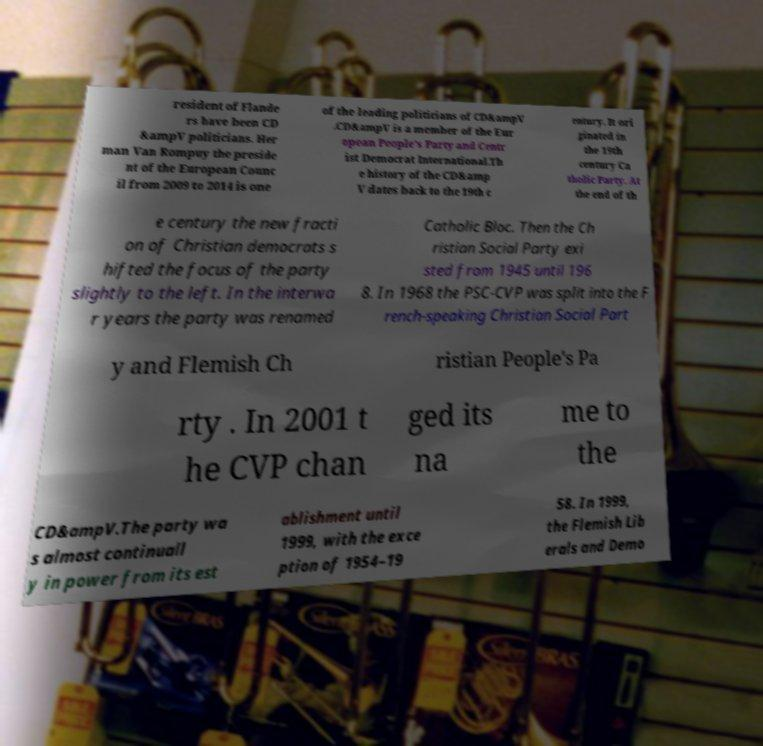What messages or text are displayed in this image? I need them in a readable, typed format. resident of Flande rs have been CD &ampV politicians. Her man Van Rompuy the preside nt of the European Counc il from 2009 to 2014 is one of the leading politicians of CD&ampV .CD&ampV is a member of the Eur opean People's Party and Centr ist Democrat International.Th e history of the CD&amp V dates back to the 19th c entury. It ori ginated in the 19th century Ca tholic Party. At the end of th e century the new fracti on of Christian democrats s hifted the focus of the party slightly to the left. In the interwa r years the party was renamed Catholic Bloc. Then the Ch ristian Social Party exi sted from 1945 until 196 8. In 1968 the PSC-CVP was split into the F rench-speaking Christian Social Part y and Flemish Ch ristian People's Pa rty . In 2001 t he CVP chan ged its na me to the CD&ampV.The party wa s almost continuall y in power from its est ablishment until 1999, with the exce ption of 1954–19 58. In 1999, the Flemish Lib erals and Demo 